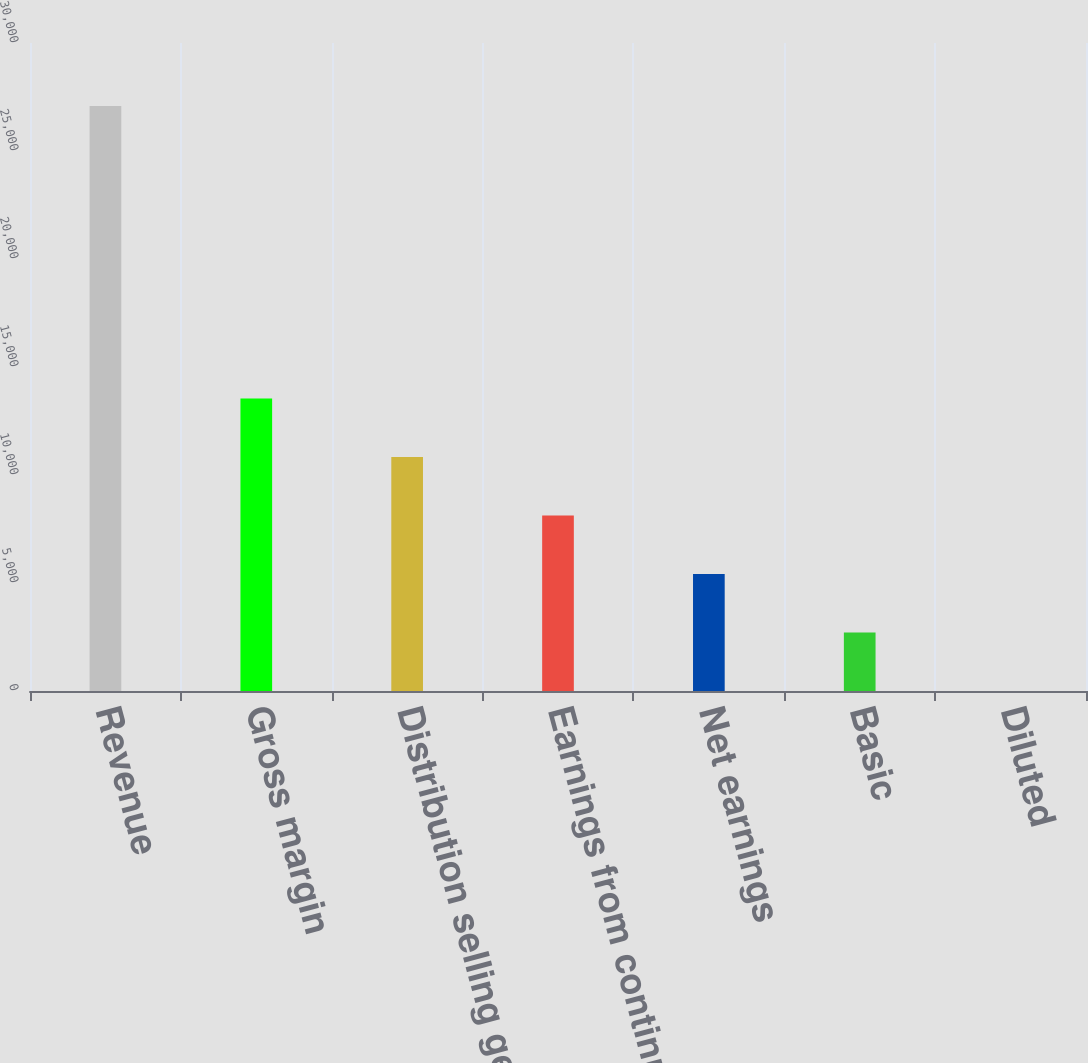<chart> <loc_0><loc_0><loc_500><loc_500><bar_chart><fcel>Revenue<fcel>Gross margin<fcel>Distribution selling general<fcel>Earnings from continuing<fcel>Net earnings<fcel>Basic<fcel>Diluted<nl><fcel>27078<fcel>13539.4<fcel>10831.6<fcel>8123.92<fcel>5416.2<fcel>2708.48<fcel>0.76<nl></chart> 